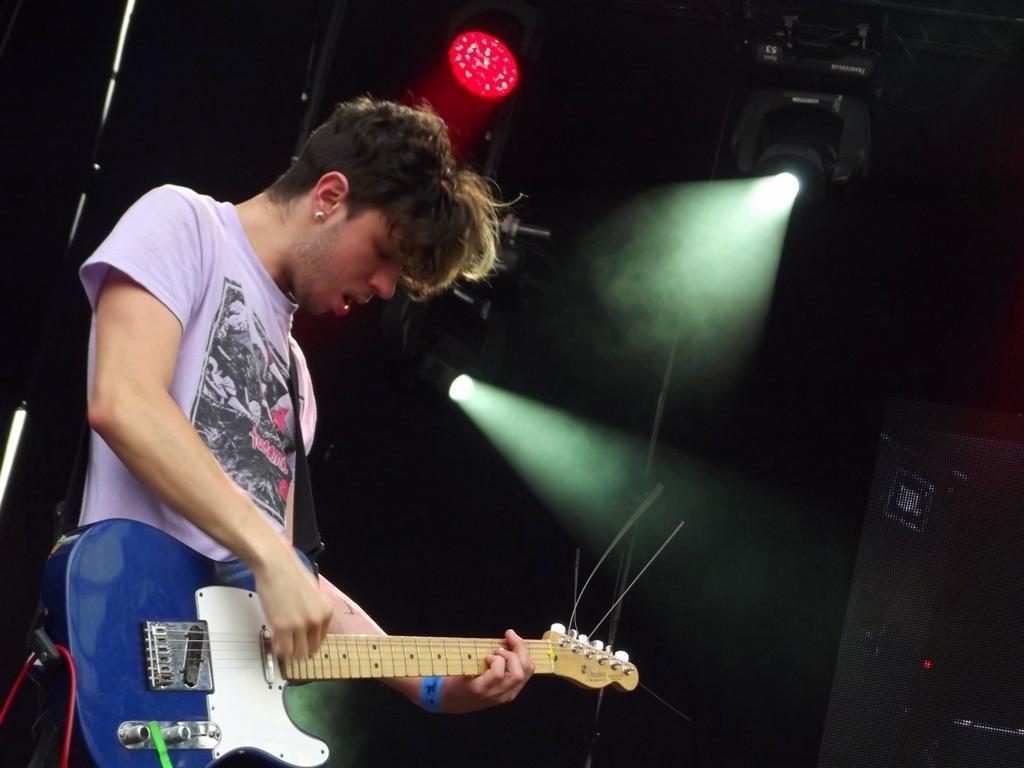Please provide a concise description of this image. In this image there is a person wearing a white color T-shirt playing a musical instrument and at the right side of the image there is a light and at the bottom right of the image there is a sound box. 